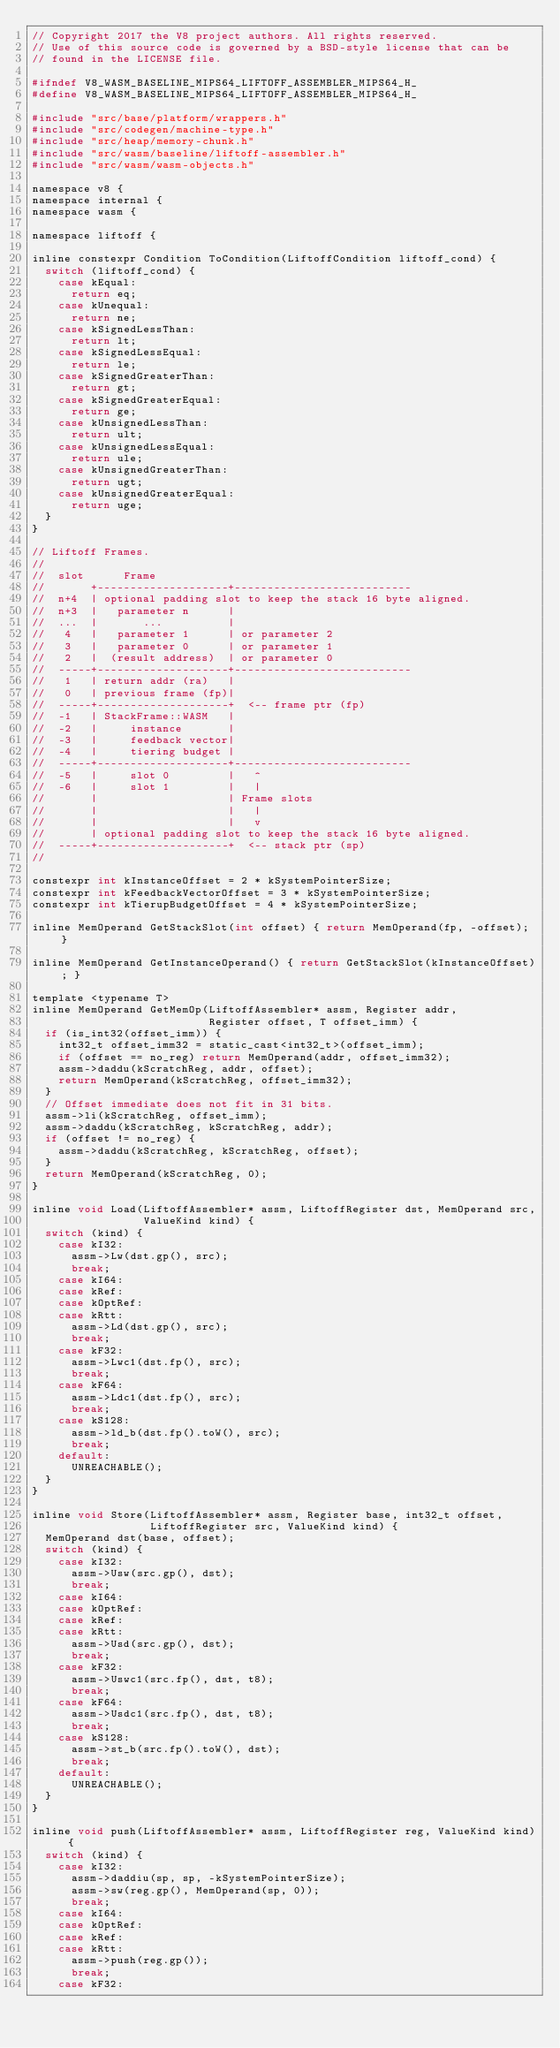<code> <loc_0><loc_0><loc_500><loc_500><_C_>// Copyright 2017 the V8 project authors. All rights reserved.
// Use of this source code is governed by a BSD-style license that can be
// found in the LICENSE file.

#ifndef V8_WASM_BASELINE_MIPS64_LIFTOFF_ASSEMBLER_MIPS64_H_
#define V8_WASM_BASELINE_MIPS64_LIFTOFF_ASSEMBLER_MIPS64_H_

#include "src/base/platform/wrappers.h"
#include "src/codegen/machine-type.h"
#include "src/heap/memory-chunk.h"
#include "src/wasm/baseline/liftoff-assembler.h"
#include "src/wasm/wasm-objects.h"

namespace v8 {
namespace internal {
namespace wasm {

namespace liftoff {

inline constexpr Condition ToCondition(LiftoffCondition liftoff_cond) {
  switch (liftoff_cond) {
    case kEqual:
      return eq;
    case kUnequal:
      return ne;
    case kSignedLessThan:
      return lt;
    case kSignedLessEqual:
      return le;
    case kSignedGreaterThan:
      return gt;
    case kSignedGreaterEqual:
      return ge;
    case kUnsignedLessThan:
      return ult;
    case kUnsignedLessEqual:
      return ule;
    case kUnsignedGreaterThan:
      return ugt;
    case kUnsignedGreaterEqual:
      return uge;
  }
}

// Liftoff Frames.
//
//  slot      Frame
//       +--------------------+---------------------------
//  n+4  | optional padding slot to keep the stack 16 byte aligned.
//  n+3  |   parameter n      |
//  ...  |       ...          |
//   4   |   parameter 1      | or parameter 2
//   3   |   parameter 0      | or parameter 1
//   2   |  (result address)  | or parameter 0
//  -----+--------------------+---------------------------
//   1   | return addr (ra)   |
//   0   | previous frame (fp)|
//  -----+--------------------+  <-- frame ptr (fp)
//  -1   | StackFrame::WASM   |
//  -2   |     instance       |
//  -3   |     feedback vector|
//  -4   |     tiering budget |
//  -----+--------------------+---------------------------
//  -5   |     slot 0         |   ^
//  -6   |     slot 1         |   |
//       |                    | Frame slots
//       |                    |   |
//       |                    |   v
//       | optional padding slot to keep the stack 16 byte aligned.
//  -----+--------------------+  <-- stack ptr (sp)
//

constexpr int kInstanceOffset = 2 * kSystemPointerSize;
constexpr int kFeedbackVectorOffset = 3 * kSystemPointerSize;
constexpr int kTierupBudgetOffset = 4 * kSystemPointerSize;

inline MemOperand GetStackSlot(int offset) { return MemOperand(fp, -offset); }

inline MemOperand GetInstanceOperand() { return GetStackSlot(kInstanceOffset); }

template <typename T>
inline MemOperand GetMemOp(LiftoffAssembler* assm, Register addr,
                           Register offset, T offset_imm) {
  if (is_int32(offset_imm)) {
    int32_t offset_imm32 = static_cast<int32_t>(offset_imm);
    if (offset == no_reg) return MemOperand(addr, offset_imm32);
    assm->daddu(kScratchReg, addr, offset);
    return MemOperand(kScratchReg, offset_imm32);
  }
  // Offset immediate does not fit in 31 bits.
  assm->li(kScratchReg, offset_imm);
  assm->daddu(kScratchReg, kScratchReg, addr);
  if (offset != no_reg) {
    assm->daddu(kScratchReg, kScratchReg, offset);
  }
  return MemOperand(kScratchReg, 0);
}

inline void Load(LiftoffAssembler* assm, LiftoffRegister dst, MemOperand src,
                 ValueKind kind) {
  switch (kind) {
    case kI32:
      assm->Lw(dst.gp(), src);
      break;
    case kI64:
    case kRef:
    case kOptRef:
    case kRtt:
      assm->Ld(dst.gp(), src);
      break;
    case kF32:
      assm->Lwc1(dst.fp(), src);
      break;
    case kF64:
      assm->Ldc1(dst.fp(), src);
      break;
    case kS128:
      assm->ld_b(dst.fp().toW(), src);
      break;
    default:
      UNREACHABLE();
  }
}

inline void Store(LiftoffAssembler* assm, Register base, int32_t offset,
                  LiftoffRegister src, ValueKind kind) {
  MemOperand dst(base, offset);
  switch (kind) {
    case kI32:
      assm->Usw(src.gp(), dst);
      break;
    case kI64:
    case kOptRef:
    case kRef:
    case kRtt:
      assm->Usd(src.gp(), dst);
      break;
    case kF32:
      assm->Uswc1(src.fp(), dst, t8);
      break;
    case kF64:
      assm->Usdc1(src.fp(), dst, t8);
      break;
    case kS128:
      assm->st_b(src.fp().toW(), dst);
      break;
    default:
      UNREACHABLE();
  }
}

inline void push(LiftoffAssembler* assm, LiftoffRegister reg, ValueKind kind) {
  switch (kind) {
    case kI32:
      assm->daddiu(sp, sp, -kSystemPointerSize);
      assm->sw(reg.gp(), MemOperand(sp, 0));
      break;
    case kI64:
    case kOptRef:
    case kRef:
    case kRtt:
      assm->push(reg.gp());
      break;
    case kF32:</code> 